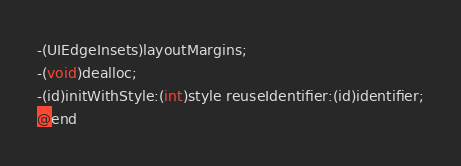<code> <loc_0><loc_0><loc_500><loc_500><_C_>-(UIEdgeInsets)layoutMargins;
-(void)dealloc;
-(id)initWithStyle:(int)style reuseIdentifier:(id)identifier;
@end

</code> 